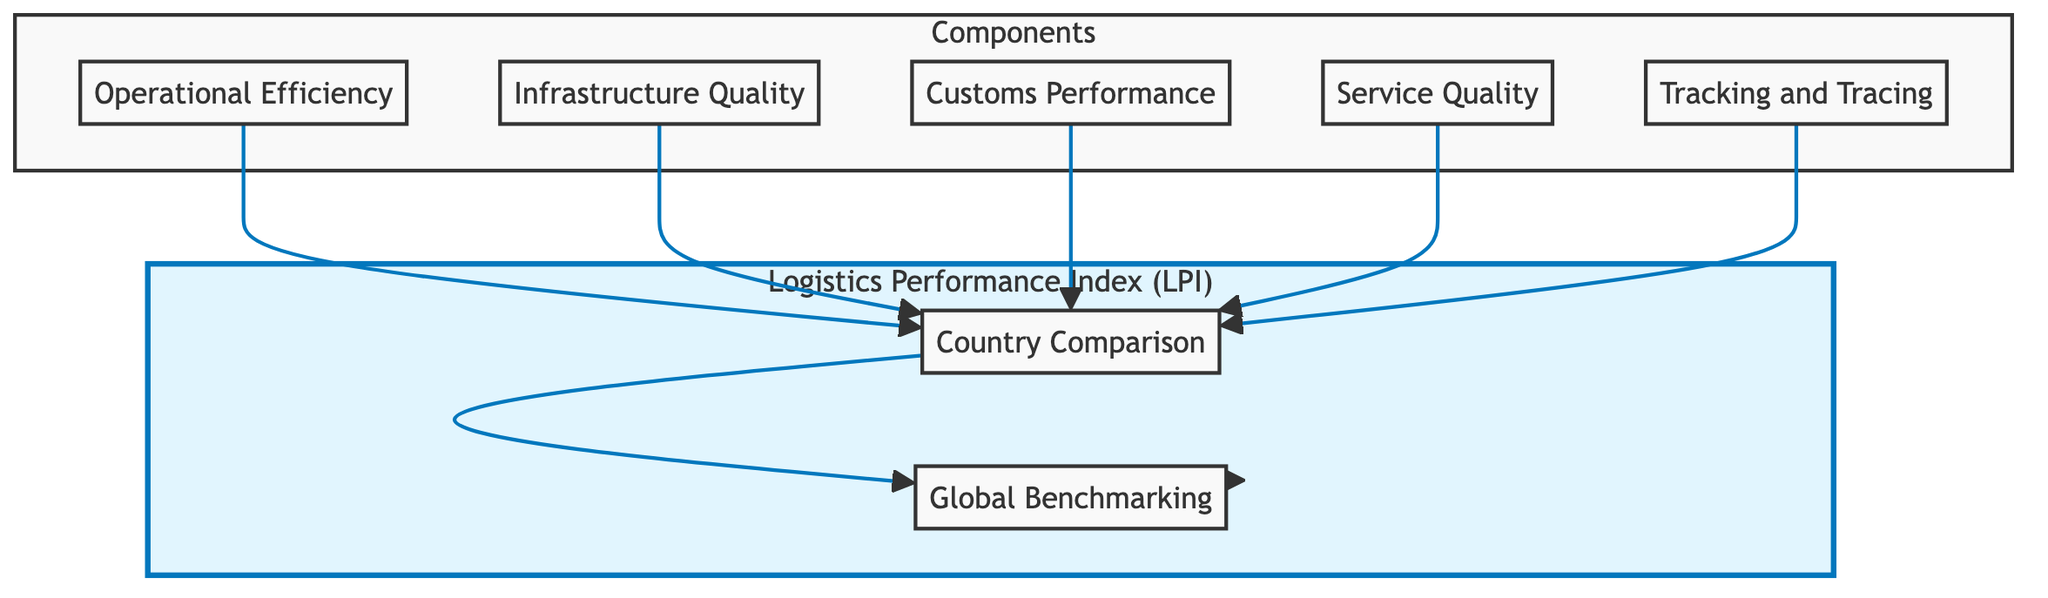What are the main components of the LPI? The main components of the LPI are Operational Efficiency, Infrastructure Quality, Customs Performance, Service Quality, and Tracking and Tracing, as indicated in the Components subgraph.
Answer: Operational Efficiency, Infrastructure Quality, Customs Performance, Service Quality, Tracking and Tracing How many elements are in the Logistics Performance Index section? There are two elements in the Logistics Performance Index section: Country Comparison and Global Benchmarking, as indicated in the LPI subgraph.
Answer: 2 Which component directly supports the Country Comparison node? All components (Operational Efficiency, Infrastructure Quality, Customs Performance, Service Quality, and Tracking and Tracing) support the Country Comparison node as they all connect to it.
Answer: All components What does the Global Benchmarking node do? The Global Benchmarking node contextualizes the logistics performance of countries' scores against global averages by connecting Country Comparison to LPI.
Answer: Contextualizes scores How many connections are there between components and Country Comparison? There are five connections leading from the components (C, D, E, F, G) to the Country Comparison node.
Answer: 5 What is the relationship of the Country Comparison node to the Logistics Performance Index? The Country Comparison node feeds into Global Benchmarking, which then contributes to the overall Logistics Performance Index (LPI), indicating a hierarchical relationship.
Answer: Feeds into LPI Which node is highlighted in the diagram? The Logistics Performance Index (LPI) is highlighted, distinguishing it as the key focus of the diagram.
Answer: Logistics Performance Index What is assessed by the Customs Performance component? The Customs Performance component assesses the effectiveness and efficiency of customs clearance processes in different countries.
Answer: Customs clearance processes What does Tracking and Tracing evaluate? The Tracking and Tracing component evaluates the availability and effectiveness of tracking systems that enhance supply chain visibility.
Answer: Tracking systems visibility 